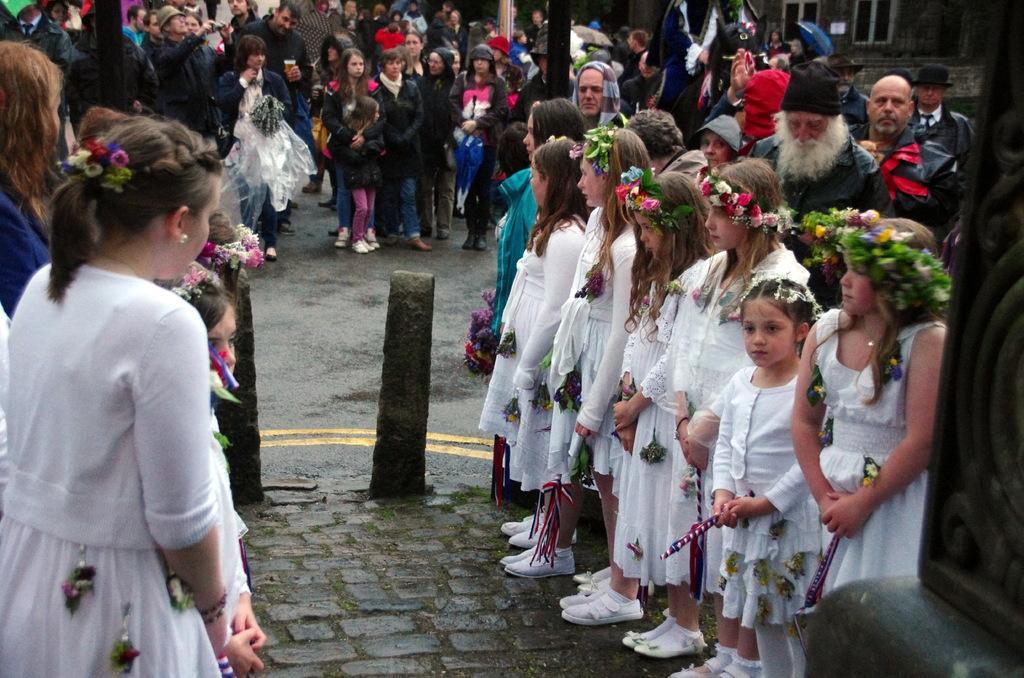Please provide a concise description of this image. In this picture we can see a group of people standing on the ground, stones and some objects. In the background we can see an umbrella, windows and the wall. 